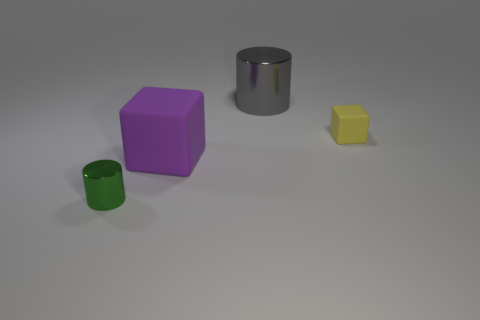Add 1 yellow blocks. How many objects exist? 5 Subtract all gray cylinders. How many cylinders are left? 1 Subtract all brown blocks. Subtract all cyan spheres. How many blocks are left? 2 Subtract all yellow cylinders. How many brown blocks are left? 0 Subtract all red metal cubes. Subtract all gray cylinders. How many objects are left? 3 Add 3 large purple blocks. How many large purple blocks are left? 4 Add 2 green shiny things. How many green shiny things exist? 3 Subtract 0 gray cubes. How many objects are left? 4 